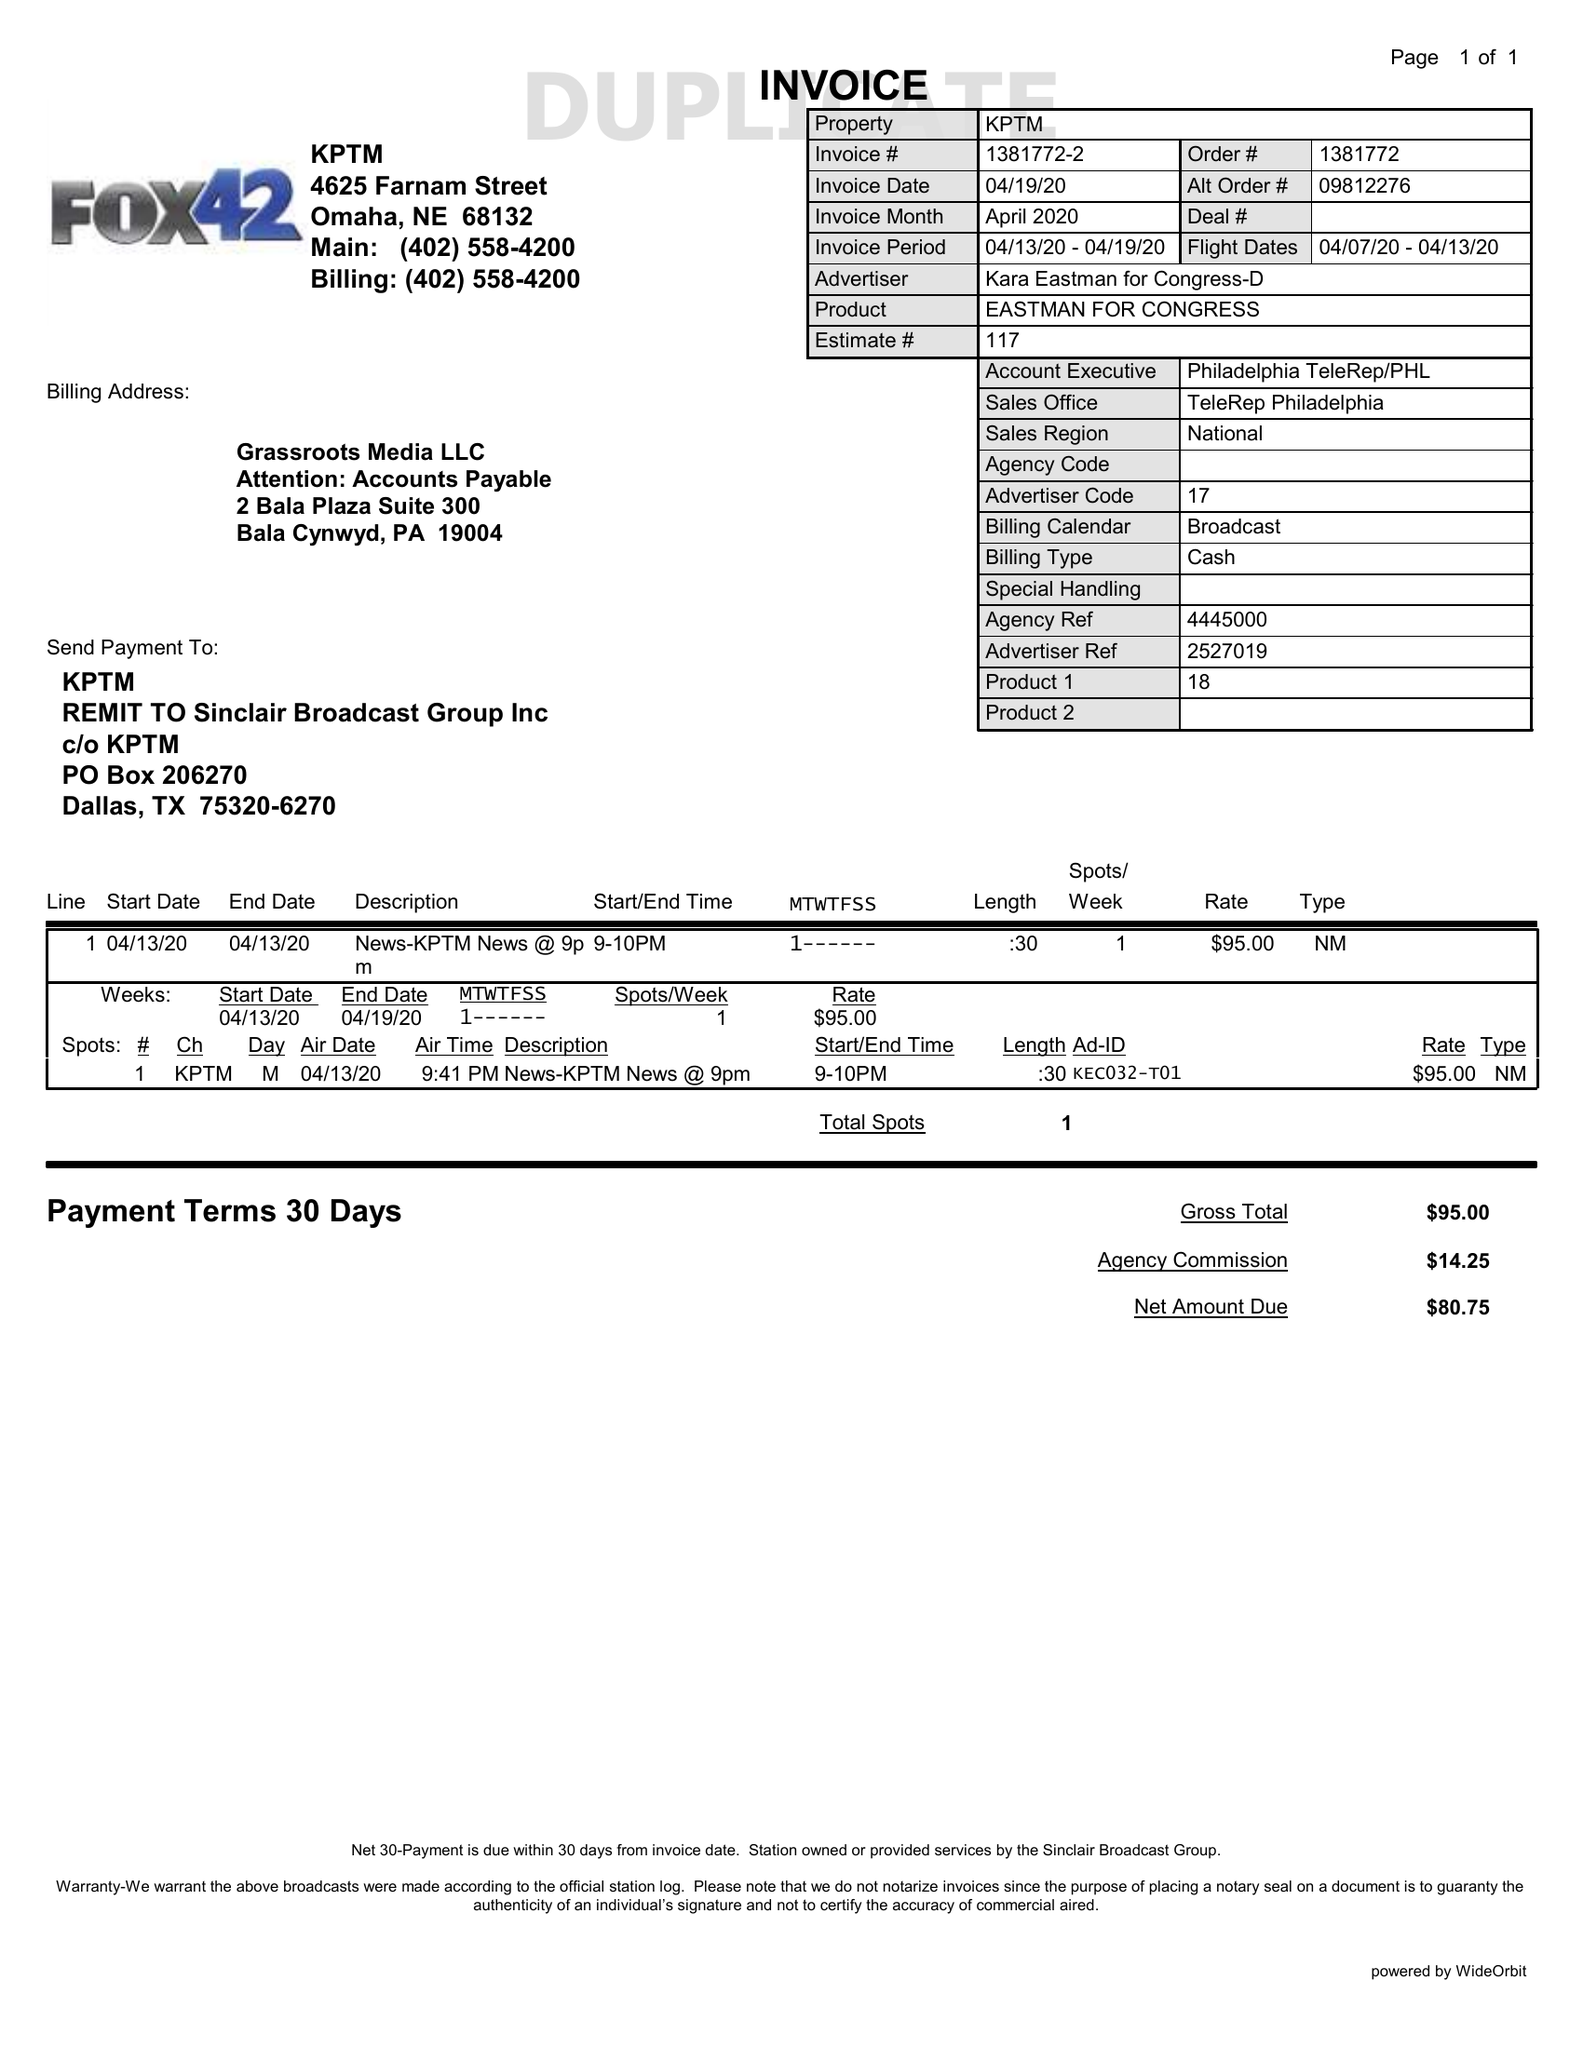What is the value for the advertiser?
Answer the question using a single word or phrase. KARA EASTMAN FOR CONGRESS-D 